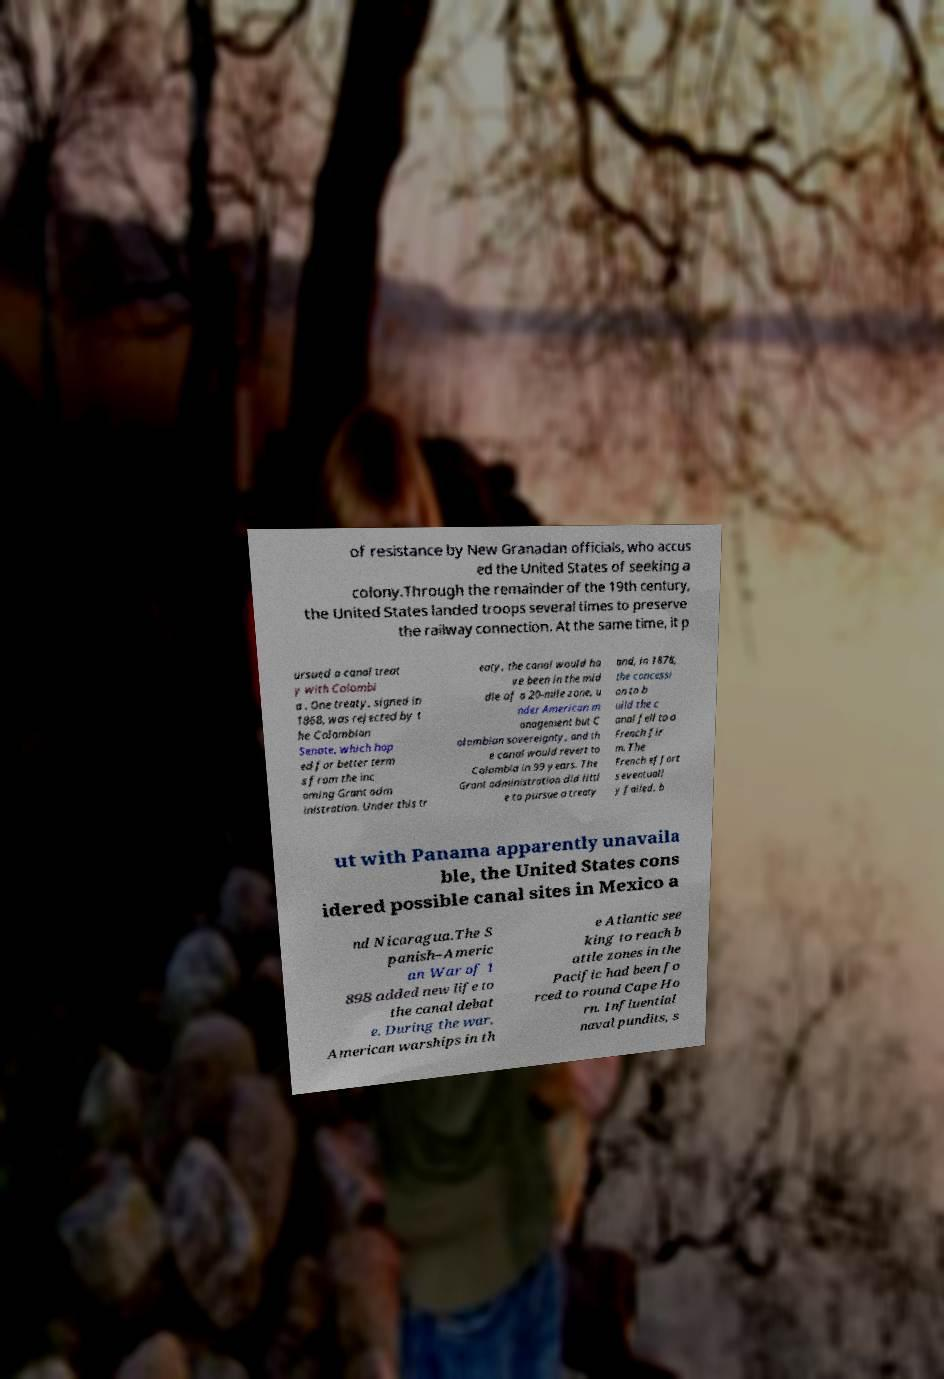What messages or text are displayed in this image? I need them in a readable, typed format. of resistance by New Granadan officials, who accus ed the United States of seeking a colony.Through the remainder of the 19th century, the United States landed troops several times to preserve the railway connection. At the same time, it p ursued a canal treat y with Colombi a . One treaty, signed in 1868, was rejected by t he Colombian Senate, which hop ed for better term s from the inc oming Grant adm inistration. Under this tr eaty, the canal would ha ve been in the mid dle of a 20-mile zone, u nder American m anagement but C olombian sovereignty, and th e canal would revert to Colombia in 99 years. The Grant administration did littl e to pursue a treaty and, in 1878, the concessi on to b uild the c anal fell to a French fir m. The French effort s eventuall y failed, b ut with Panama apparently unavaila ble, the United States cons idered possible canal sites in Mexico a nd Nicaragua.The S panish–Americ an War of 1 898 added new life to the canal debat e. During the war, American warships in th e Atlantic see king to reach b attle zones in the Pacific had been fo rced to round Cape Ho rn. Influential naval pundits, s 